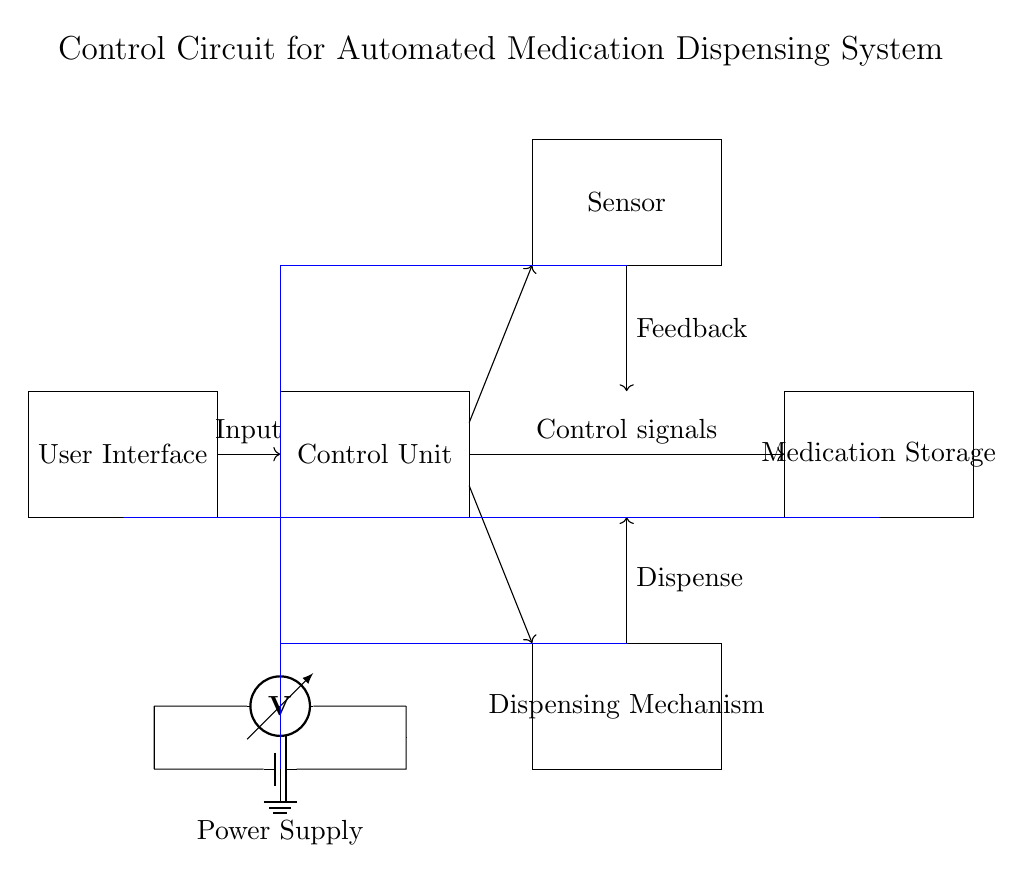What is the function of the control unit? The control unit processes input from the user interface, sends control signals to the dispensing mechanism, and manages overall operations within the system.
Answer: Control signals What are the two key inputs to the dispensing mechanism? The dispensing mechanism receives inputs from the control unit (for actions to be executed) and user interface (instructions or requests from users).
Answer: Control unit, User interface What type of component is used for the power supply? The power supply is represented by a battery symbol in the circuit diagram, which is a common component for providing electrical energy.
Answer: Battery What does the sensor provide to the control unit? The sensor provides feedback concerning the status of the dispensing mechanism or medication levels, which the control unit uses to make further decisions or adjustments.
Answer: Feedback How many main components are directly involved in the medication dispensing circuit? There are five main components involved: Control unit, User interface, Sensor, Medication storage, and Dispensing mechanism.
Answer: Five What is the role of the user interface in the circuit? The user interface enables healthcare personnel to input commands or requests into the system, allowing for controlled dispensing of medications based on user specifications.
Answer: Input commands 